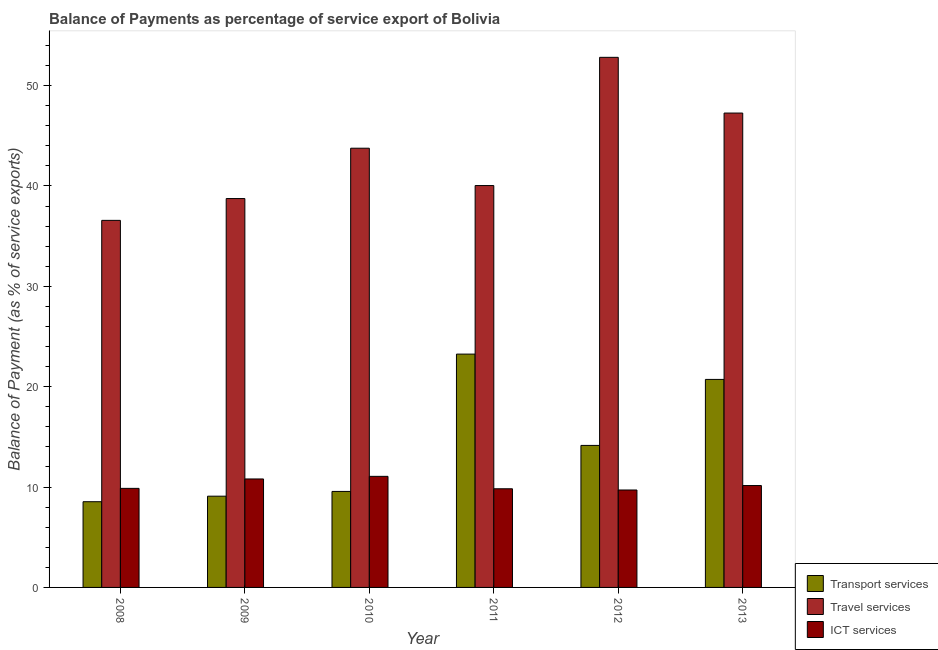How many different coloured bars are there?
Your response must be concise. 3. Are the number of bars on each tick of the X-axis equal?
Make the answer very short. Yes. How many bars are there on the 3rd tick from the left?
Provide a succinct answer. 3. How many bars are there on the 1st tick from the right?
Your answer should be very brief. 3. What is the balance of payment of travel services in 2010?
Ensure brevity in your answer.  43.76. Across all years, what is the maximum balance of payment of transport services?
Ensure brevity in your answer.  23.25. Across all years, what is the minimum balance of payment of travel services?
Make the answer very short. 36.57. In which year was the balance of payment of ict services maximum?
Make the answer very short. 2010. What is the total balance of payment of ict services in the graph?
Your answer should be very brief. 61.43. What is the difference between the balance of payment of ict services in 2010 and that in 2012?
Offer a terse response. 1.36. What is the difference between the balance of payment of transport services in 2010 and the balance of payment of travel services in 2012?
Give a very brief answer. -4.58. What is the average balance of payment of travel services per year?
Offer a terse response. 43.2. In the year 2008, what is the difference between the balance of payment of ict services and balance of payment of transport services?
Give a very brief answer. 0. In how many years, is the balance of payment of ict services greater than 34 %?
Provide a succinct answer. 0. What is the ratio of the balance of payment of transport services in 2009 to that in 2010?
Make the answer very short. 0.95. Is the difference between the balance of payment of travel services in 2008 and 2013 greater than the difference between the balance of payment of ict services in 2008 and 2013?
Make the answer very short. No. What is the difference between the highest and the second highest balance of payment of transport services?
Provide a short and direct response. 2.52. What is the difference between the highest and the lowest balance of payment of travel services?
Give a very brief answer. 16.24. Is the sum of the balance of payment of travel services in 2011 and 2012 greater than the maximum balance of payment of ict services across all years?
Your answer should be compact. Yes. What does the 2nd bar from the left in 2009 represents?
Offer a very short reply. Travel services. What does the 3rd bar from the right in 2012 represents?
Your answer should be very brief. Transport services. Are all the bars in the graph horizontal?
Offer a terse response. No. Are the values on the major ticks of Y-axis written in scientific E-notation?
Offer a very short reply. No. How many legend labels are there?
Your answer should be very brief. 3. How are the legend labels stacked?
Ensure brevity in your answer.  Vertical. What is the title of the graph?
Keep it short and to the point. Balance of Payments as percentage of service export of Bolivia. Does "Labor Tax" appear as one of the legend labels in the graph?
Offer a terse response. No. What is the label or title of the X-axis?
Your answer should be compact. Year. What is the label or title of the Y-axis?
Offer a very short reply. Balance of Payment (as % of service exports). What is the Balance of Payment (as % of service exports) of Transport services in 2008?
Offer a terse response. 8.54. What is the Balance of Payment (as % of service exports) of Travel services in 2008?
Provide a succinct answer. 36.57. What is the Balance of Payment (as % of service exports) in ICT services in 2008?
Provide a succinct answer. 9.87. What is the Balance of Payment (as % of service exports) in Transport services in 2009?
Ensure brevity in your answer.  9.09. What is the Balance of Payment (as % of service exports) of Travel services in 2009?
Provide a succinct answer. 38.75. What is the Balance of Payment (as % of service exports) in ICT services in 2009?
Your answer should be very brief. 10.81. What is the Balance of Payment (as % of service exports) in Transport services in 2010?
Keep it short and to the point. 9.57. What is the Balance of Payment (as % of service exports) in Travel services in 2010?
Make the answer very short. 43.76. What is the Balance of Payment (as % of service exports) in ICT services in 2010?
Offer a terse response. 11.07. What is the Balance of Payment (as % of service exports) in Transport services in 2011?
Provide a succinct answer. 23.25. What is the Balance of Payment (as % of service exports) of Travel services in 2011?
Ensure brevity in your answer.  40.04. What is the Balance of Payment (as % of service exports) in ICT services in 2011?
Keep it short and to the point. 9.83. What is the Balance of Payment (as % of service exports) of Transport services in 2012?
Your response must be concise. 14.15. What is the Balance of Payment (as % of service exports) of Travel services in 2012?
Provide a succinct answer. 52.82. What is the Balance of Payment (as % of service exports) in ICT services in 2012?
Keep it short and to the point. 9.71. What is the Balance of Payment (as % of service exports) in Transport services in 2013?
Ensure brevity in your answer.  20.73. What is the Balance of Payment (as % of service exports) in Travel services in 2013?
Keep it short and to the point. 47.26. What is the Balance of Payment (as % of service exports) in ICT services in 2013?
Your response must be concise. 10.15. Across all years, what is the maximum Balance of Payment (as % of service exports) of Transport services?
Offer a very short reply. 23.25. Across all years, what is the maximum Balance of Payment (as % of service exports) of Travel services?
Keep it short and to the point. 52.82. Across all years, what is the maximum Balance of Payment (as % of service exports) of ICT services?
Your answer should be compact. 11.07. Across all years, what is the minimum Balance of Payment (as % of service exports) of Transport services?
Give a very brief answer. 8.54. Across all years, what is the minimum Balance of Payment (as % of service exports) in Travel services?
Provide a short and direct response. 36.57. Across all years, what is the minimum Balance of Payment (as % of service exports) of ICT services?
Your answer should be very brief. 9.71. What is the total Balance of Payment (as % of service exports) in Transport services in the graph?
Offer a very short reply. 85.32. What is the total Balance of Payment (as % of service exports) of Travel services in the graph?
Ensure brevity in your answer.  259.2. What is the total Balance of Payment (as % of service exports) in ICT services in the graph?
Offer a terse response. 61.43. What is the difference between the Balance of Payment (as % of service exports) of Transport services in 2008 and that in 2009?
Give a very brief answer. -0.55. What is the difference between the Balance of Payment (as % of service exports) in Travel services in 2008 and that in 2009?
Give a very brief answer. -2.17. What is the difference between the Balance of Payment (as % of service exports) in ICT services in 2008 and that in 2009?
Your response must be concise. -0.94. What is the difference between the Balance of Payment (as % of service exports) in Transport services in 2008 and that in 2010?
Keep it short and to the point. -1.03. What is the difference between the Balance of Payment (as % of service exports) in Travel services in 2008 and that in 2010?
Make the answer very short. -7.19. What is the difference between the Balance of Payment (as % of service exports) of ICT services in 2008 and that in 2010?
Your answer should be very brief. -1.2. What is the difference between the Balance of Payment (as % of service exports) in Transport services in 2008 and that in 2011?
Keep it short and to the point. -14.71. What is the difference between the Balance of Payment (as % of service exports) of Travel services in 2008 and that in 2011?
Make the answer very short. -3.47. What is the difference between the Balance of Payment (as % of service exports) in ICT services in 2008 and that in 2011?
Offer a terse response. 0.04. What is the difference between the Balance of Payment (as % of service exports) in Transport services in 2008 and that in 2012?
Provide a succinct answer. -5.61. What is the difference between the Balance of Payment (as % of service exports) in Travel services in 2008 and that in 2012?
Your response must be concise. -16.24. What is the difference between the Balance of Payment (as % of service exports) in ICT services in 2008 and that in 2012?
Provide a succinct answer. 0.16. What is the difference between the Balance of Payment (as % of service exports) in Transport services in 2008 and that in 2013?
Provide a succinct answer. -12.19. What is the difference between the Balance of Payment (as % of service exports) in Travel services in 2008 and that in 2013?
Offer a terse response. -10.69. What is the difference between the Balance of Payment (as % of service exports) in ICT services in 2008 and that in 2013?
Your response must be concise. -0.28. What is the difference between the Balance of Payment (as % of service exports) of Transport services in 2009 and that in 2010?
Offer a terse response. -0.47. What is the difference between the Balance of Payment (as % of service exports) in Travel services in 2009 and that in 2010?
Give a very brief answer. -5.02. What is the difference between the Balance of Payment (as % of service exports) in ICT services in 2009 and that in 2010?
Your answer should be very brief. -0.26. What is the difference between the Balance of Payment (as % of service exports) in Transport services in 2009 and that in 2011?
Your answer should be compact. -14.16. What is the difference between the Balance of Payment (as % of service exports) in Travel services in 2009 and that in 2011?
Your response must be concise. -1.3. What is the difference between the Balance of Payment (as % of service exports) of ICT services in 2009 and that in 2011?
Provide a short and direct response. 0.98. What is the difference between the Balance of Payment (as % of service exports) of Transport services in 2009 and that in 2012?
Your answer should be compact. -5.06. What is the difference between the Balance of Payment (as % of service exports) of Travel services in 2009 and that in 2012?
Your response must be concise. -14.07. What is the difference between the Balance of Payment (as % of service exports) of ICT services in 2009 and that in 2012?
Your answer should be compact. 1.1. What is the difference between the Balance of Payment (as % of service exports) in Transport services in 2009 and that in 2013?
Your response must be concise. -11.63. What is the difference between the Balance of Payment (as % of service exports) in Travel services in 2009 and that in 2013?
Provide a short and direct response. -8.52. What is the difference between the Balance of Payment (as % of service exports) of ICT services in 2009 and that in 2013?
Keep it short and to the point. 0.66. What is the difference between the Balance of Payment (as % of service exports) of Transport services in 2010 and that in 2011?
Make the answer very short. -13.68. What is the difference between the Balance of Payment (as % of service exports) in Travel services in 2010 and that in 2011?
Make the answer very short. 3.72. What is the difference between the Balance of Payment (as % of service exports) in ICT services in 2010 and that in 2011?
Keep it short and to the point. 1.24. What is the difference between the Balance of Payment (as % of service exports) of Transport services in 2010 and that in 2012?
Your answer should be compact. -4.58. What is the difference between the Balance of Payment (as % of service exports) of Travel services in 2010 and that in 2012?
Ensure brevity in your answer.  -9.06. What is the difference between the Balance of Payment (as % of service exports) of ICT services in 2010 and that in 2012?
Make the answer very short. 1.36. What is the difference between the Balance of Payment (as % of service exports) in Transport services in 2010 and that in 2013?
Make the answer very short. -11.16. What is the difference between the Balance of Payment (as % of service exports) of Travel services in 2010 and that in 2013?
Offer a very short reply. -3.5. What is the difference between the Balance of Payment (as % of service exports) in ICT services in 2010 and that in 2013?
Your response must be concise. 0.92. What is the difference between the Balance of Payment (as % of service exports) of Transport services in 2011 and that in 2012?
Make the answer very short. 9.1. What is the difference between the Balance of Payment (as % of service exports) of Travel services in 2011 and that in 2012?
Your answer should be very brief. -12.78. What is the difference between the Balance of Payment (as % of service exports) of ICT services in 2011 and that in 2012?
Make the answer very short. 0.12. What is the difference between the Balance of Payment (as % of service exports) of Transport services in 2011 and that in 2013?
Offer a terse response. 2.52. What is the difference between the Balance of Payment (as % of service exports) of Travel services in 2011 and that in 2013?
Keep it short and to the point. -7.22. What is the difference between the Balance of Payment (as % of service exports) of ICT services in 2011 and that in 2013?
Your answer should be compact. -0.32. What is the difference between the Balance of Payment (as % of service exports) in Transport services in 2012 and that in 2013?
Your answer should be compact. -6.58. What is the difference between the Balance of Payment (as % of service exports) of Travel services in 2012 and that in 2013?
Offer a very short reply. 5.55. What is the difference between the Balance of Payment (as % of service exports) of ICT services in 2012 and that in 2013?
Give a very brief answer. -0.44. What is the difference between the Balance of Payment (as % of service exports) in Transport services in 2008 and the Balance of Payment (as % of service exports) in Travel services in 2009?
Ensure brevity in your answer.  -30.21. What is the difference between the Balance of Payment (as % of service exports) of Transport services in 2008 and the Balance of Payment (as % of service exports) of ICT services in 2009?
Keep it short and to the point. -2.27. What is the difference between the Balance of Payment (as % of service exports) of Travel services in 2008 and the Balance of Payment (as % of service exports) of ICT services in 2009?
Offer a very short reply. 25.76. What is the difference between the Balance of Payment (as % of service exports) in Transport services in 2008 and the Balance of Payment (as % of service exports) in Travel services in 2010?
Keep it short and to the point. -35.22. What is the difference between the Balance of Payment (as % of service exports) in Transport services in 2008 and the Balance of Payment (as % of service exports) in ICT services in 2010?
Ensure brevity in your answer.  -2.53. What is the difference between the Balance of Payment (as % of service exports) of Travel services in 2008 and the Balance of Payment (as % of service exports) of ICT services in 2010?
Keep it short and to the point. 25.51. What is the difference between the Balance of Payment (as % of service exports) in Transport services in 2008 and the Balance of Payment (as % of service exports) in Travel services in 2011?
Your response must be concise. -31.5. What is the difference between the Balance of Payment (as % of service exports) in Transport services in 2008 and the Balance of Payment (as % of service exports) in ICT services in 2011?
Your response must be concise. -1.29. What is the difference between the Balance of Payment (as % of service exports) in Travel services in 2008 and the Balance of Payment (as % of service exports) in ICT services in 2011?
Ensure brevity in your answer.  26.74. What is the difference between the Balance of Payment (as % of service exports) in Transport services in 2008 and the Balance of Payment (as % of service exports) in Travel services in 2012?
Ensure brevity in your answer.  -44.28. What is the difference between the Balance of Payment (as % of service exports) of Transport services in 2008 and the Balance of Payment (as % of service exports) of ICT services in 2012?
Keep it short and to the point. -1.17. What is the difference between the Balance of Payment (as % of service exports) in Travel services in 2008 and the Balance of Payment (as % of service exports) in ICT services in 2012?
Your answer should be compact. 26.86. What is the difference between the Balance of Payment (as % of service exports) in Transport services in 2008 and the Balance of Payment (as % of service exports) in Travel services in 2013?
Your response must be concise. -38.72. What is the difference between the Balance of Payment (as % of service exports) in Transport services in 2008 and the Balance of Payment (as % of service exports) in ICT services in 2013?
Your answer should be very brief. -1.61. What is the difference between the Balance of Payment (as % of service exports) in Travel services in 2008 and the Balance of Payment (as % of service exports) in ICT services in 2013?
Provide a short and direct response. 26.42. What is the difference between the Balance of Payment (as % of service exports) of Transport services in 2009 and the Balance of Payment (as % of service exports) of Travel services in 2010?
Offer a terse response. -34.67. What is the difference between the Balance of Payment (as % of service exports) in Transport services in 2009 and the Balance of Payment (as % of service exports) in ICT services in 2010?
Your answer should be very brief. -1.98. What is the difference between the Balance of Payment (as % of service exports) of Travel services in 2009 and the Balance of Payment (as % of service exports) of ICT services in 2010?
Make the answer very short. 27.68. What is the difference between the Balance of Payment (as % of service exports) of Transport services in 2009 and the Balance of Payment (as % of service exports) of Travel services in 2011?
Provide a succinct answer. -30.95. What is the difference between the Balance of Payment (as % of service exports) of Transport services in 2009 and the Balance of Payment (as % of service exports) of ICT services in 2011?
Your answer should be very brief. -0.74. What is the difference between the Balance of Payment (as % of service exports) of Travel services in 2009 and the Balance of Payment (as % of service exports) of ICT services in 2011?
Your answer should be compact. 28.92. What is the difference between the Balance of Payment (as % of service exports) in Transport services in 2009 and the Balance of Payment (as % of service exports) in Travel services in 2012?
Provide a short and direct response. -43.73. What is the difference between the Balance of Payment (as % of service exports) of Transport services in 2009 and the Balance of Payment (as % of service exports) of ICT services in 2012?
Ensure brevity in your answer.  -0.62. What is the difference between the Balance of Payment (as % of service exports) of Travel services in 2009 and the Balance of Payment (as % of service exports) of ICT services in 2012?
Your answer should be compact. 29.04. What is the difference between the Balance of Payment (as % of service exports) in Transport services in 2009 and the Balance of Payment (as % of service exports) in Travel services in 2013?
Keep it short and to the point. -38.17. What is the difference between the Balance of Payment (as % of service exports) in Transport services in 2009 and the Balance of Payment (as % of service exports) in ICT services in 2013?
Offer a terse response. -1.06. What is the difference between the Balance of Payment (as % of service exports) in Travel services in 2009 and the Balance of Payment (as % of service exports) in ICT services in 2013?
Offer a terse response. 28.59. What is the difference between the Balance of Payment (as % of service exports) of Transport services in 2010 and the Balance of Payment (as % of service exports) of Travel services in 2011?
Ensure brevity in your answer.  -30.48. What is the difference between the Balance of Payment (as % of service exports) of Transport services in 2010 and the Balance of Payment (as % of service exports) of ICT services in 2011?
Provide a succinct answer. -0.26. What is the difference between the Balance of Payment (as % of service exports) of Travel services in 2010 and the Balance of Payment (as % of service exports) of ICT services in 2011?
Give a very brief answer. 33.93. What is the difference between the Balance of Payment (as % of service exports) of Transport services in 2010 and the Balance of Payment (as % of service exports) of Travel services in 2012?
Your response must be concise. -43.25. What is the difference between the Balance of Payment (as % of service exports) in Transport services in 2010 and the Balance of Payment (as % of service exports) in ICT services in 2012?
Your answer should be very brief. -0.14. What is the difference between the Balance of Payment (as % of service exports) of Travel services in 2010 and the Balance of Payment (as % of service exports) of ICT services in 2012?
Keep it short and to the point. 34.05. What is the difference between the Balance of Payment (as % of service exports) of Transport services in 2010 and the Balance of Payment (as % of service exports) of Travel services in 2013?
Ensure brevity in your answer.  -37.7. What is the difference between the Balance of Payment (as % of service exports) in Transport services in 2010 and the Balance of Payment (as % of service exports) in ICT services in 2013?
Give a very brief answer. -0.59. What is the difference between the Balance of Payment (as % of service exports) in Travel services in 2010 and the Balance of Payment (as % of service exports) in ICT services in 2013?
Offer a very short reply. 33.61. What is the difference between the Balance of Payment (as % of service exports) in Transport services in 2011 and the Balance of Payment (as % of service exports) in Travel services in 2012?
Keep it short and to the point. -29.57. What is the difference between the Balance of Payment (as % of service exports) of Transport services in 2011 and the Balance of Payment (as % of service exports) of ICT services in 2012?
Your answer should be compact. 13.54. What is the difference between the Balance of Payment (as % of service exports) of Travel services in 2011 and the Balance of Payment (as % of service exports) of ICT services in 2012?
Your answer should be very brief. 30.33. What is the difference between the Balance of Payment (as % of service exports) in Transport services in 2011 and the Balance of Payment (as % of service exports) in Travel services in 2013?
Your response must be concise. -24.02. What is the difference between the Balance of Payment (as % of service exports) in Transport services in 2011 and the Balance of Payment (as % of service exports) in ICT services in 2013?
Your answer should be very brief. 13.1. What is the difference between the Balance of Payment (as % of service exports) of Travel services in 2011 and the Balance of Payment (as % of service exports) of ICT services in 2013?
Provide a succinct answer. 29.89. What is the difference between the Balance of Payment (as % of service exports) of Transport services in 2012 and the Balance of Payment (as % of service exports) of Travel services in 2013?
Ensure brevity in your answer.  -33.12. What is the difference between the Balance of Payment (as % of service exports) of Transport services in 2012 and the Balance of Payment (as % of service exports) of ICT services in 2013?
Provide a short and direct response. 4. What is the difference between the Balance of Payment (as % of service exports) of Travel services in 2012 and the Balance of Payment (as % of service exports) of ICT services in 2013?
Your answer should be compact. 42.67. What is the average Balance of Payment (as % of service exports) of Transport services per year?
Offer a very short reply. 14.22. What is the average Balance of Payment (as % of service exports) in Travel services per year?
Provide a succinct answer. 43.2. What is the average Balance of Payment (as % of service exports) of ICT services per year?
Your answer should be very brief. 10.24. In the year 2008, what is the difference between the Balance of Payment (as % of service exports) of Transport services and Balance of Payment (as % of service exports) of Travel services?
Provide a short and direct response. -28.03. In the year 2008, what is the difference between the Balance of Payment (as % of service exports) in Transport services and Balance of Payment (as % of service exports) in ICT services?
Provide a succinct answer. -1.33. In the year 2008, what is the difference between the Balance of Payment (as % of service exports) in Travel services and Balance of Payment (as % of service exports) in ICT services?
Provide a short and direct response. 26.7. In the year 2009, what is the difference between the Balance of Payment (as % of service exports) in Transport services and Balance of Payment (as % of service exports) in Travel services?
Keep it short and to the point. -29.65. In the year 2009, what is the difference between the Balance of Payment (as % of service exports) of Transport services and Balance of Payment (as % of service exports) of ICT services?
Keep it short and to the point. -1.72. In the year 2009, what is the difference between the Balance of Payment (as % of service exports) of Travel services and Balance of Payment (as % of service exports) of ICT services?
Give a very brief answer. 27.94. In the year 2010, what is the difference between the Balance of Payment (as % of service exports) of Transport services and Balance of Payment (as % of service exports) of Travel services?
Make the answer very short. -34.2. In the year 2010, what is the difference between the Balance of Payment (as % of service exports) of Transport services and Balance of Payment (as % of service exports) of ICT services?
Your response must be concise. -1.5. In the year 2010, what is the difference between the Balance of Payment (as % of service exports) of Travel services and Balance of Payment (as % of service exports) of ICT services?
Your response must be concise. 32.69. In the year 2011, what is the difference between the Balance of Payment (as % of service exports) of Transport services and Balance of Payment (as % of service exports) of Travel services?
Offer a very short reply. -16.79. In the year 2011, what is the difference between the Balance of Payment (as % of service exports) of Transport services and Balance of Payment (as % of service exports) of ICT services?
Offer a terse response. 13.42. In the year 2011, what is the difference between the Balance of Payment (as % of service exports) in Travel services and Balance of Payment (as % of service exports) in ICT services?
Your answer should be compact. 30.21. In the year 2012, what is the difference between the Balance of Payment (as % of service exports) of Transport services and Balance of Payment (as % of service exports) of Travel services?
Your response must be concise. -38.67. In the year 2012, what is the difference between the Balance of Payment (as % of service exports) in Transport services and Balance of Payment (as % of service exports) in ICT services?
Offer a very short reply. 4.44. In the year 2012, what is the difference between the Balance of Payment (as % of service exports) in Travel services and Balance of Payment (as % of service exports) in ICT services?
Ensure brevity in your answer.  43.11. In the year 2013, what is the difference between the Balance of Payment (as % of service exports) of Transport services and Balance of Payment (as % of service exports) of Travel services?
Provide a succinct answer. -26.54. In the year 2013, what is the difference between the Balance of Payment (as % of service exports) in Transport services and Balance of Payment (as % of service exports) in ICT services?
Provide a succinct answer. 10.57. In the year 2013, what is the difference between the Balance of Payment (as % of service exports) in Travel services and Balance of Payment (as % of service exports) in ICT services?
Offer a very short reply. 37.11. What is the ratio of the Balance of Payment (as % of service exports) in Transport services in 2008 to that in 2009?
Your response must be concise. 0.94. What is the ratio of the Balance of Payment (as % of service exports) in Travel services in 2008 to that in 2009?
Your answer should be compact. 0.94. What is the ratio of the Balance of Payment (as % of service exports) of ICT services in 2008 to that in 2009?
Your answer should be compact. 0.91. What is the ratio of the Balance of Payment (as % of service exports) in Transport services in 2008 to that in 2010?
Your answer should be compact. 0.89. What is the ratio of the Balance of Payment (as % of service exports) in Travel services in 2008 to that in 2010?
Provide a short and direct response. 0.84. What is the ratio of the Balance of Payment (as % of service exports) of ICT services in 2008 to that in 2010?
Your response must be concise. 0.89. What is the ratio of the Balance of Payment (as % of service exports) in Transport services in 2008 to that in 2011?
Your answer should be compact. 0.37. What is the ratio of the Balance of Payment (as % of service exports) in Travel services in 2008 to that in 2011?
Provide a short and direct response. 0.91. What is the ratio of the Balance of Payment (as % of service exports) of ICT services in 2008 to that in 2011?
Give a very brief answer. 1. What is the ratio of the Balance of Payment (as % of service exports) in Transport services in 2008 to that in 2012?
Offer a terse response. 0.6. What is the ratio of the Balance of Payment (as % of service exports) of Travel services in 2008 to that in 2012?
Your response must be concise. 0.69. What is the ratio of the Balance of Payment (as % of service exports) of ICT services in 2008 to that in 2012?
Provide a short and direct response. 1.02. What is the ratio of the Balance of Payment (as % of service exports) of Transport services in 2008 to that in 2013?
Keep it short and to the point. 0.41. What is the ratio of the Balance of Payment (as % of service exports) of Travel services in 2008 to that in 2013?
Make the answer very short. 0.77. What is the ratio of the Balance of Payment (as % of service exports) of ICT services in 2008 to that in 2013?
Keep it short and to the point. 0.97. What is the ratio of the Balance of Payment (as % of service exports) in Transport services in 2009 to that in 2010?
Your answer should be compact. 0.95. What is the ratio of the Balance of Payment (as % of service exports) of Travel services in 2009 to that in 2010?
Keep it short and to the point. 0.89. What is the ratio of the Balance of Payment (as % of service exports) of ICT services in 2009 to that in 2010?
Keep it short and to the point. 0.98. What is the ratio of the Balance of Payment (as % of service exports) of Transport services in 2009 to that in 2011?
Offer a very short reply. 0.39. What is the ratio of the Balance of Payment (as % of service exports) of Travel services in 2009 to that in 2011?
Keep it short and to the point. 0.97. What is the ratio of the Balance of Payment (as % of service exports) of ICT services in 2009 to that in 2011?
Your answer should be compact. 1.1. What is the ratio of the Balance of Payment (as % of service exports) of Transport services in 2009 to that in 2012?
Keep it short and to the point. 0.64. What is the ratio of the Balance of Payment (as % of service exports) of Travel services in 2009 to that in 2012?
Ensure brevity in your answer.  0.73. What is the ratio of the Balance of Payment (as % of service exports) of ICT services in 2009 to that in 2012?
Provide a short and direct response. 1.11. What is the ratio of the Balance of Payment (as % of service exports) of Transport services in 2009 to that in 2013?
Keep it short and to the point. 0.44. What is the ratio of the Balance of Payment (as % of service exports) of Travel services in 2009 to that in 2013?
Make the answer very short. 0.82. What is the ratio of the Balance of Payment (as % of service exports) of ICT services in 2009 to that in 2013?
Your answer should be compact. 1.06. What is the ratio of the Balance of Payment (as % of service exports) of Transport services in 2010 to that in 2011?
Offer a terse response. 0.41. What is the ratio of the Balance of Payment (as % of service exports) in Travel services in 2010 to that in 2011?
Keep it short and to the point. 1.09. What is the ratio of the Balance of Payment (as % of service exports) of ICT services in 2010 to that in 2011?
Keep it short and to the point. 1.13. What is the ratio of the Balance of Payment (as % of service exports) of Transport services in 2010 to that in 2012?
Keep it short and to the point. 0.68. What is the ratio of the Balance of Payment (as % of service exports) in Travel services in 2010 to that in 2012?
Offer a very short reply. 0.83. What is the ratio of the Balance of Payment (as % of service exports) in ICT services in 2010 to that in 2012?
Your answer should be compact. 1.14. What is the ratio of the Balance of Payment (as % of service exports) of Transport services in 2010 to that in 2013?
Ensure brevity in your answer.  0.46. What is the ratio of the Balance of Payment (as % of service exports) of Travel services in 2010 to that in 2013?
Keep it short and to the point. 0.93. What is the ratio of the Balance of Payment (as % of service exports) of ICT services in 2010 to that in 2013?
Ensure brevity in your answer.  1.09. What is the ratio of the Balance of Payment (as % of service exports) of Transport services in 2011 to that in 2012?
Your answer should be very brief. 1.64. What is the ratio of the Balance of Payment (as % of service exports) of Travel services in 2011 to that in 2012?
Make the answer very short. 0.76. What is the ratio of the Balance of Payment (as % of service exports) in ICT services in 2011 to that in 2012?
Provide a succinct answer. 1.01. What is the ratio of the Balance of Payment (as % of service exports) of Transport services in 2011 to that in 2013?
Give a very brief answer. 1.12. What is the ratio of the Balance of Payment (as % of service exports) in Travel services in 2011 to that in 2013?
Your answer should be very brief. 0.85. What is the ratio of the Balance of Payment (as % of service exports) of ICT services in 2011 to that in 2013?
Your answer should be compact. 0.97. What is the ratio of the Balance of Payment (as % of service exports) in Transport services in 2012 to that in 2013?
Make the answer very short. 0.68. What is the ratio of the Balance of Payment (as % of service exports) in Travel services in 2012 to that in 2013?
Your response must be concise. 1.12. What is the ratio of the Balance of Payment (as % of service exports) in ICT services in 2012 to that in 2013?
Your response must be concise. 0.96. What is the difference between the highest and the second highest Balance of Payment (as % of service exports) of Transport services?
Your response must be concise. 2.52. What is the difference between the highest and the second highest Balance of Payment (as % of service exports) of Travel services?
Your response must be concise. 5.55. What is the difference between the highest and the second highest Balance of Payment (as % of service exports) in ICT services?
Provide a short and direct response. 0.26. What is the difference between the highest and the lowest Balance of Payment (as % of service exports) of Transport services?
Offer a very short reply. 14.71. What is the difference between the highest and the lowest Balance of Payment (as % of service exports) of Travel services?
Your answer should be very brief. 16.24. What is the difference between the highest and the lowest Balance of Payment (as % of service exports) in ICT services?
Give a very brief answer. 1.36. 